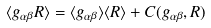Convert formula to latex. <formula><loc_0><loc_0><loc_500><loc_500>\langle g _ { \alpha \beta } R \rangle = \langle g _ { \alpha \beta } \rangle \langle R \rangle + C ( g _ { \alpha \beta } , R )</formula> 